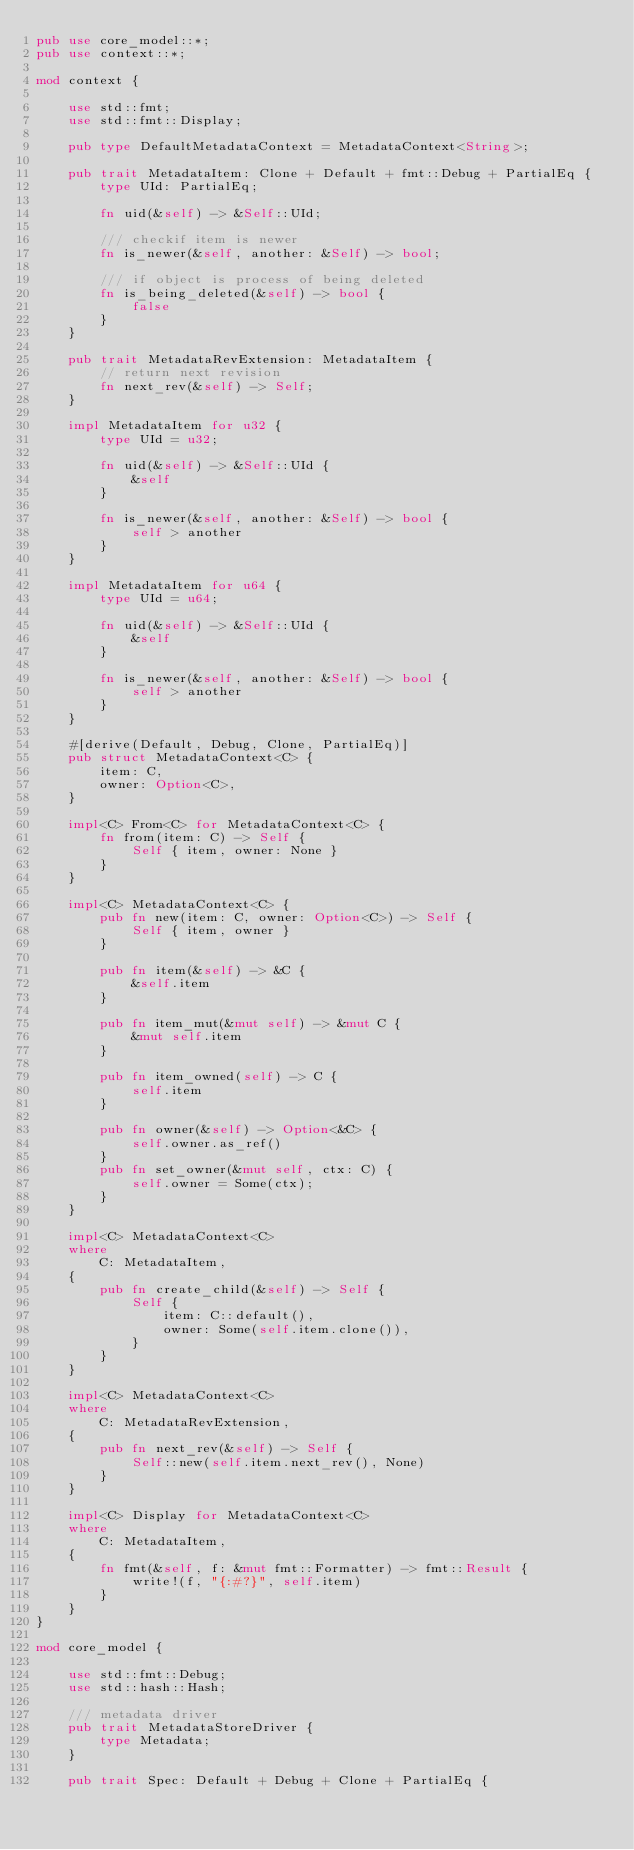<code> <loc_0><loc_0><loc_500><loc_500><_Rust_>pub use core_model::*;
pub use context::*;

mod context {

    use std::fmt;
    use std::fmt::Display;

    pub type DefaultMetadataContext = MetadataContext<String>;

    pub trait MetadataItem: Clone + Default + fmt::Debug + PartialEq {
        type UId: PartialEq;

        fn uid(&self) -> &Self::UId;

        /// checkif item is newer
        fn is_newer(&self, another: &Self) -> bool;

        /// if object is process of being deleted
        fn is_being_deleted(&self) -> bool {
            false
        }
    }

    pub trait MetadataRevExtension: MetadataItem {
        // return next revision
        fn next_rev(&self) -> Self;
    }

    impl MetadataItem for u32 {
        type UId = u32;

        fn uid(&self) -> &Self::UId {
            &self
        }

        fn is_newer(&self, another: &Self) -> bool {
            self > another
        }
    }

    impl MetadataItem for u64 {
        type UId = u64;

        fn uid(&self) -> &Self::UId {
            &self
        }

        fn is_newer(&self, another: &Self) -> bool {
            self > another
        }
    }

    #[derive(Default, Debug, Clone, PartialEq)]
    pub struct MetadataContext<C> {
        item: C,
        owner: Option<C>,
    }

    impl<C> From<C> for MetadataContext<C> {
        fn from(item: C) -> Self {
            Self { item, owner: None }
        }
    }

    impl<C> MetadataContext<C> {
        pub fn new(item: C, owner: Option<C>) -> Self {
            Self { item, owner }
        }

        pub fn item(&self) -> &C {
            &self.item
        }

        pub fn item_mut(&mut self) -> &mut C {
            &mut self.item
        }

        pub fn item_owned(self) -> C {
            self.item
        }

        pub fn owner(&self) -> Option<&C> {
            self.owner.as_ref()
        }
        pub fn set_owner(&mut self, ctx: C) {
            self.owner = Some(ctx);
        }
    }

    impl<C> MetadataContext<C>
    where
        C: MetadataItem,
    {
        pub fn create_child(&self) -> Self {
            Self {
                item: C::default(),
                owner: Some(self.item.clone()),
            }
        }
    }

    impl<C> MetadataContext<C>
    where
        C: MetadataRevExtension,
    {
        pub fn next_rev(&self) -> Self {
            Self::new(self.item.next_rev(), None)
        }
    }

    impl<C> Display for MetadataContext<C>
    where
        C: MetadataItem,
    {
        fn fmt(&self, f: &mut fmt::Formatter) -> fmt::Result {
            write!(f, "{:#?}", self.item)
        }
    }
}

mod core_model {

    use std::fmt::Debug;
    use std::hash::Hash;

    /// metadata driver
    pub trait MetadataStoreDriver {
        type Metadata;
    }

    pub trait Spec: Default + Debug + Clone + PartialEq {</code> 